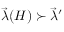Convert formula to latex. <formula><loc_0><loc_0><loc_500><loc_500>\vec { \lambda } ( H ) \succ \vec { \lambda } ^ { \prime }</formula> 